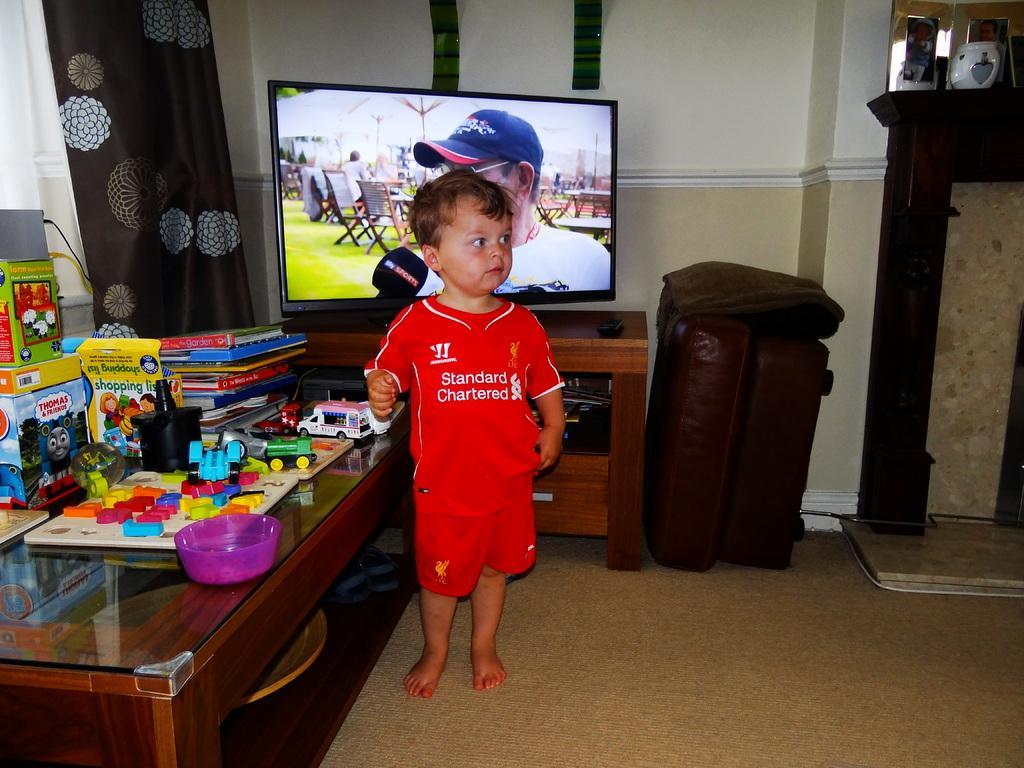How would you summarize this image in a sentence or two? In this picture I can see the floor, on which I see a child standing and I see that he is wearing red color jersey. On the left side of this image I can see a table on which there are many toys and boxes. In the background I can see the curtain, a TV, a brown color thing, few photo frames and the wall. 